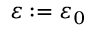Convert formula to latex. <formula><loc_0><loc_0><loc_500><loc_500>\varepsilon \colon = \varepsilon _ { 0 }</formula> 